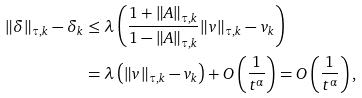Convert formula to latex. <formula><loc_0><loc_0><loc_500><loc_500>\| \delta \| _ { \tau , k } - \delta _ { k } & \leq \lambda \left ( \frac { 1 + \| A \| _ { \tau , k } } { 1 - \| A \| _ { \tau , k } } \| v \| _ { \tau , k } - v _ { k } \right ) \\ & = \lambda \left ( \| v \| _ { \tau , k } - v _ { k } \right ) + O \left ( \frac { 1 } { t ^ { \alpha } } \right ) = O \left ( \frac { 1 } { t ^ { \alpha } } \right ) ,</formula> 